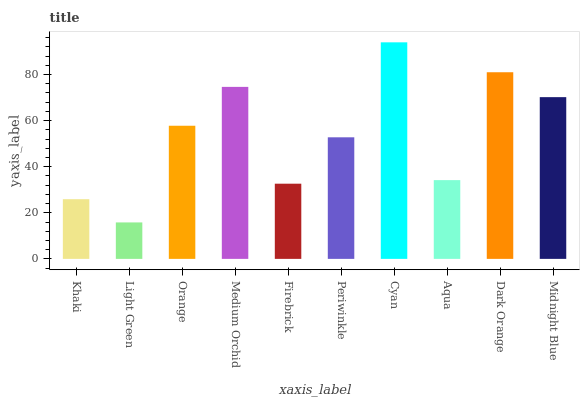Is Light Green the minimum?
Answer yes or no. Yes. Is Cyan the maximum?
Answer yes or no. Yes. Is Orange the minimum?
Answer yes or no. No. Is Orange the maximum?
Answer yes or no. No. Is Orange greater than Light Green?
Answer yes or no. Yes. Is Light Green less than Orange?
Answer yes or no. Yes. Is Light Green greater than Orange?
Answer yes or no. No. Is Orange less than Light Green?
Answer yes or no. No. Is Orange the high median?
Answer yes or no. Yes. Is Periwinkle the low median?
Answer yes or no. Yes. Is Medium Orchid the high median?
Answer yes or no. No. Is Orange the low median?
Answer yes or no. No. 